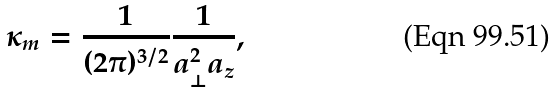<formula> <loc_0><loc_0><loc_500><loc_500>\kappa _ { m } = \frac { 1 } { ( 2 \pi ) ^ { 3 / 2 } } \frac { 1 } { a _ { \perp } ^ { 2 } a _ { z } } ,</formula> 